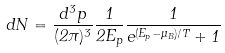Convert formula to latex. <formula><loc_0><loc_0><loc_500><loc_500>d N = \frac { d ^ { 3 } p } { ( 2 \pi ) ^ { 3 } } \frac { 1 } { 2 E _ { p } } \frac { 1 } { e ^ { ( E _ { p } - \mu _ { B } ) / T } + 1 }</formula> 